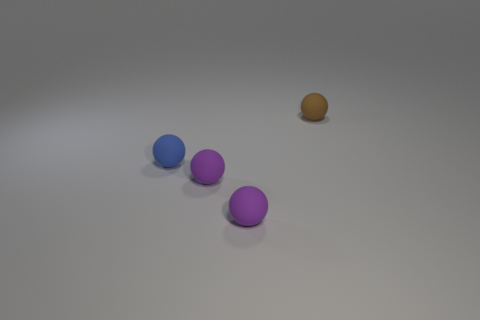Subtract all blue spheres. How many spheres are left? 3 Subtract all cyan blocks. How many purple spheres are left? 2 Subtract 3 balls. How many balls are left? 1 Add 1 large yellow spheres. How many objects exist? 5 Subtract all brown spheres. How many spheres are left? 3 Subtract all blue balls. Subtract all purple cubes. How many balls are left? 3 Subtract all small rubber things. Subtract all big red shiny cubes. How many objects are left? 0 Add 3 brown balls. How many brown balls are left? 4 Add 1 tiny rubber balls. How many tiny rubber balls exist? 5 Subtract 0 yellow cubes. How many objects are left? 4 